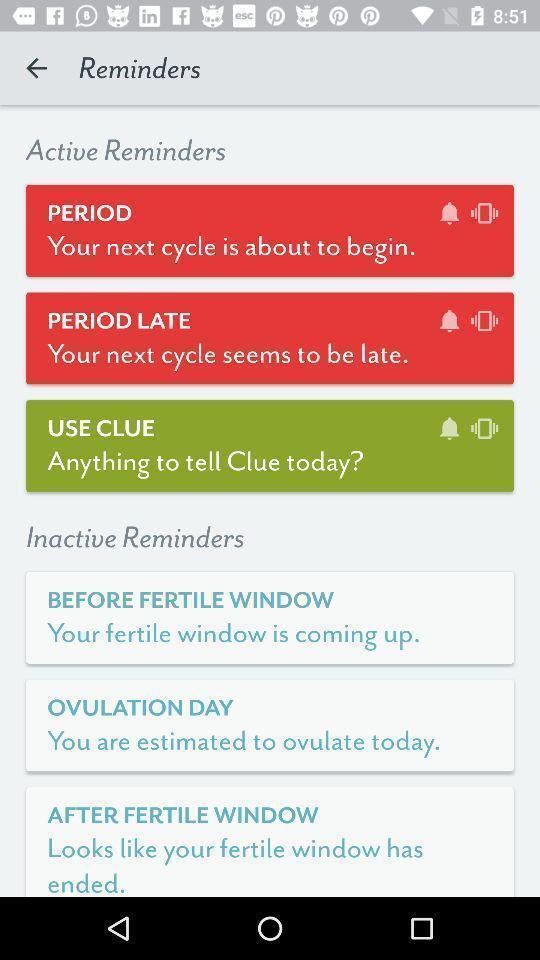Please provide a description for this image. Screen displaying multiple options in reminder page. 